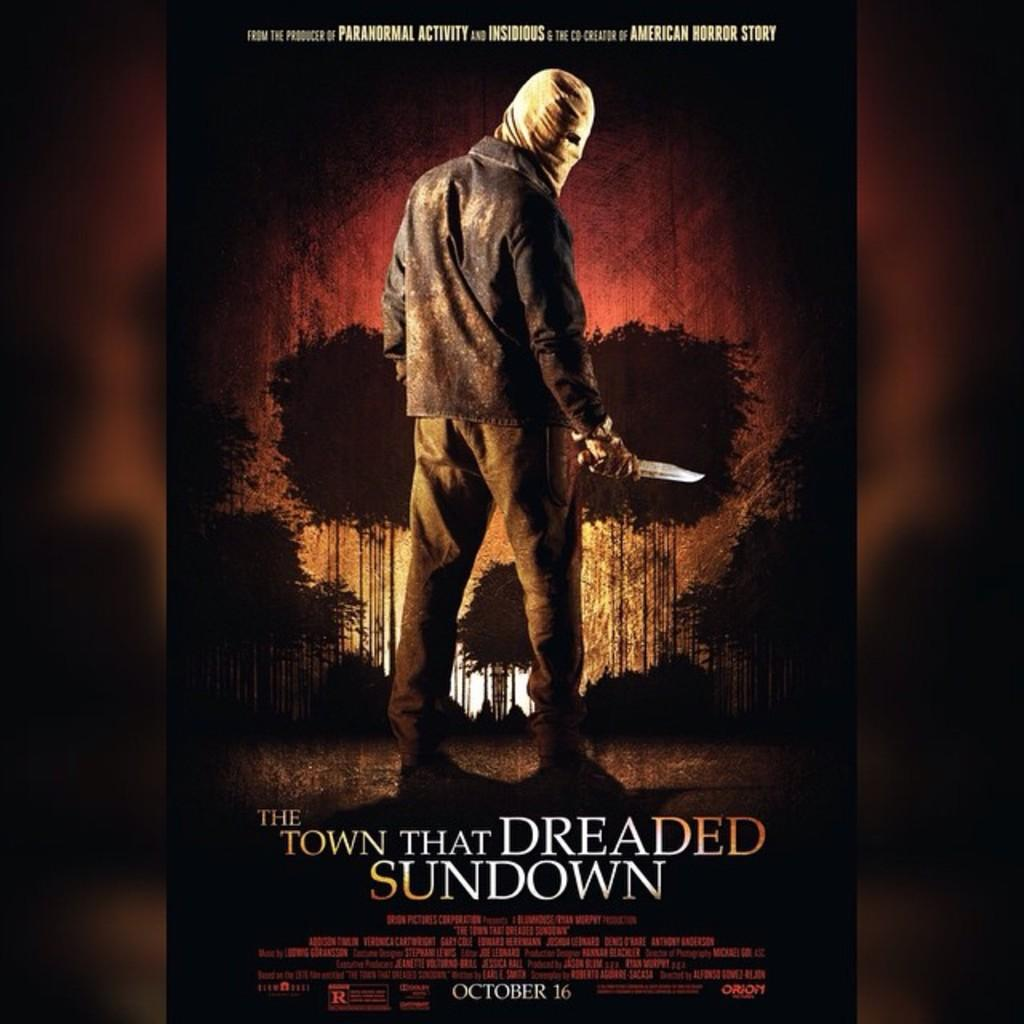<image>
Offer a succinct explanation of the picture presented. A movie poster for a movie called The Town That Dreaded Sundown that shows a man with his head covered in bandaged holding a knife in one hand. 